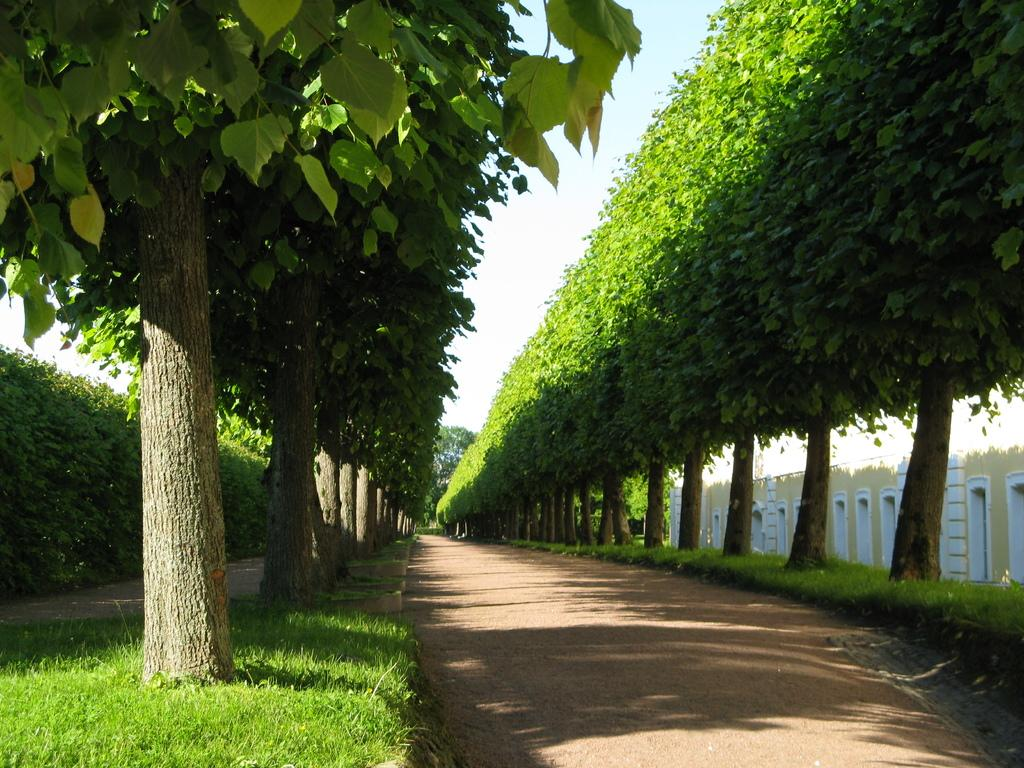What can be seen in the sky in the image? The sky is visible in the image, and clouds are present. What type of vegetation is visible in the image? Trees, plants, and grass are visible in the image. Can any structures be identified in the image? Yes, there is at least one building present in the image. What else can be seen on the ground in the image? A road is visible in the image. How many snakes are slithering on the road in the image? There are no snakes present in the image; the road is snake-free. Can you describe the kiss between the stranger and the person in the image? There is no kiss or stranger present in the image. 